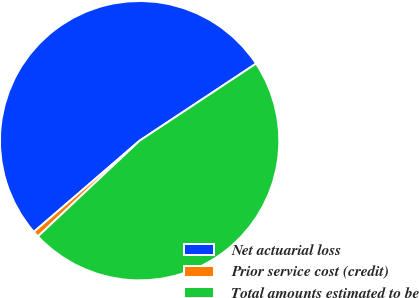<chart> <loc_0><loc_0><loc_500><loc_500><pie_chart><fcel>Net actuarial loss<fcel>Prior service cost (credit)<fcel>Total amounts estimated to be<nl><fcel>52.01%<fcel>0.7%<fcel>47.28%<nl></chart> 